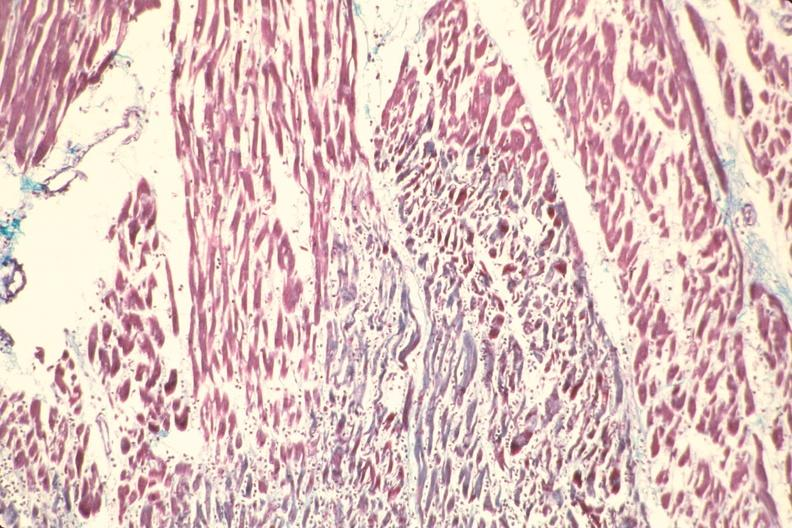do aldehyde fuscin stain?
Answer the question using a single word or phrase. Yes 